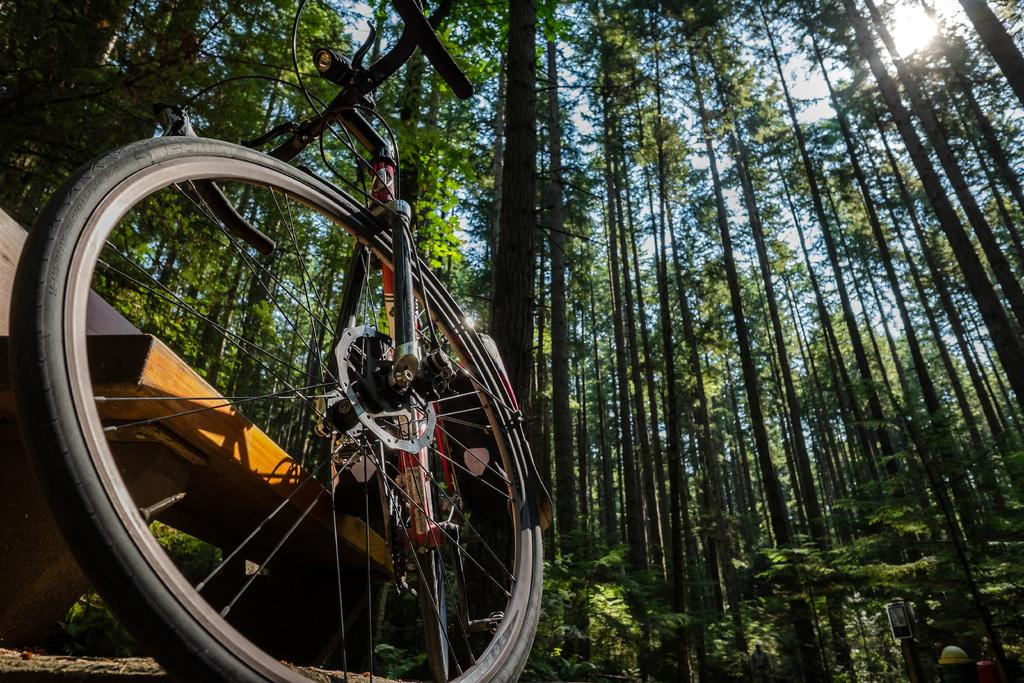What is the main subject of the image? The main subject of the image is a bicycle. Can you describe a specific part of the bicycle? The image shows a wheel of a bicycle. What type of natural environment is visible in the image? There are many trees in the image, indicating a forest or wooded area. What is visible in the background of the image? The sky is visible in the image. What type of kitten can be seen playing with a lunch box in the image? There is no kitten or lunch box present in the image; it features a bicycle and its wheel in a wooded area. Is there a mountain visible in the image? There is no mountain visible in the image; it shows a bicycle, its wheel, trees, and the sky. 